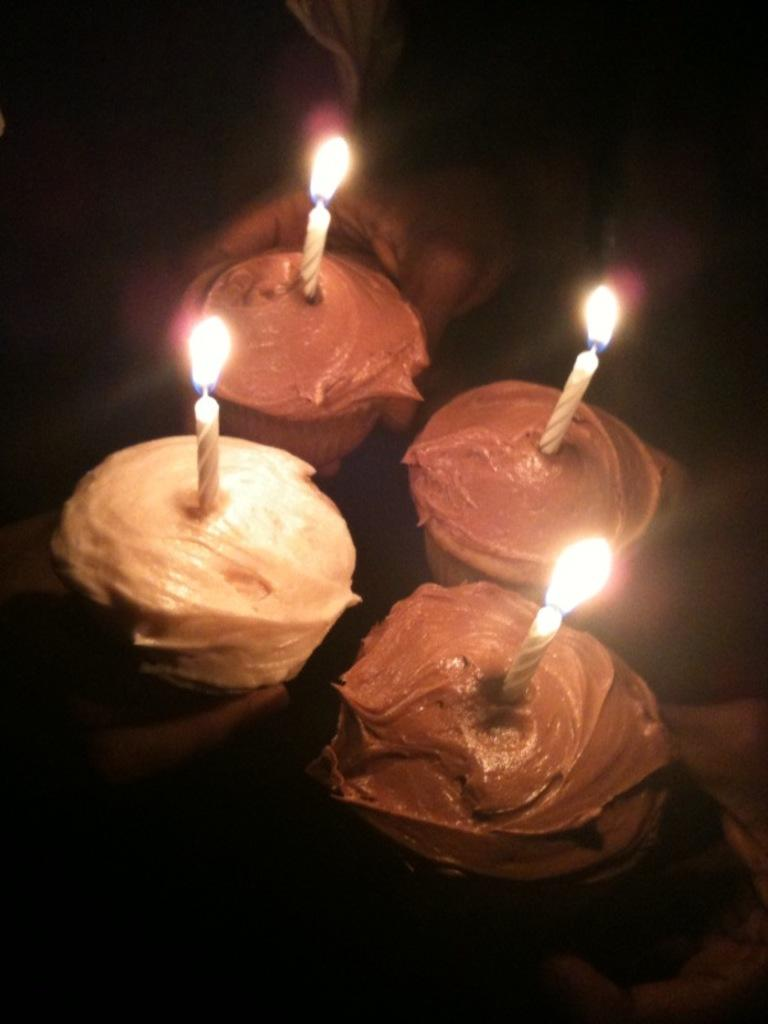What objects are present in the image that provide light? There are candles in the image. What type of sustenance can be seen in the image? There is food in the image. What type of lock is used to secure the invention in the image? There is no lock or invention present in the image; it only features candles and food. 